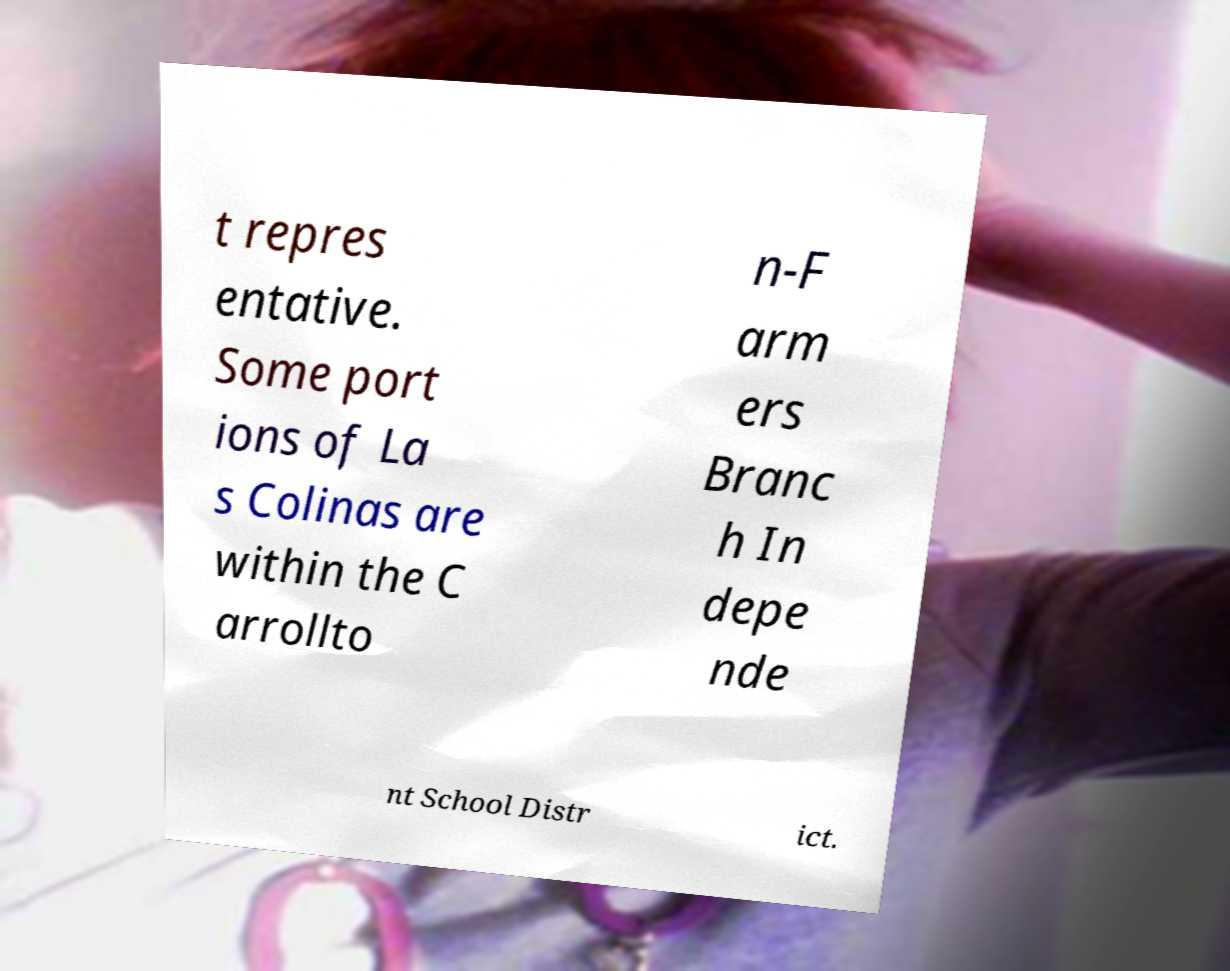Can you read and provide the text displayed in the image?This photo seems to have some interesting text. Can you extract and type it out for me? t repres entative. Some port ions of La s Colinas are within the C arrollto n-F arm ers Branc h In depe nde nt School Distr ict. 